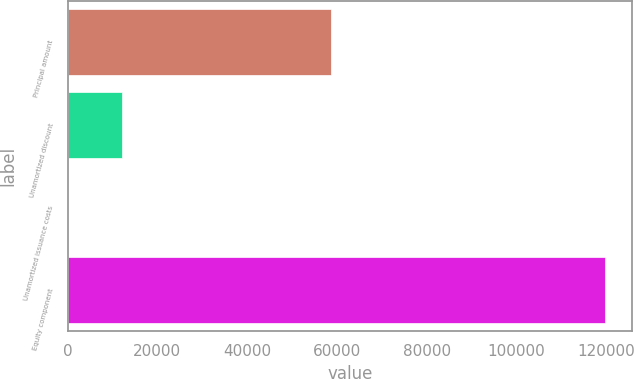Convert chart to OTSL. <chart><loc_0><loc_0><loc_500><loc_500><bar_chart><fcel>Principal amount<fcel>Unamortized discount<fcel>Unamortized issuance costs<fcel>Equity component<nl><fcel>58782<fcel>12048.9<fcel>85<fcel>119724<nl></chart> 